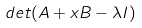Convert formula to latex. <formula><loc_0><loc_0><loc_500><loc_500>d e t ( A + x B - \lambda I )</formula> 